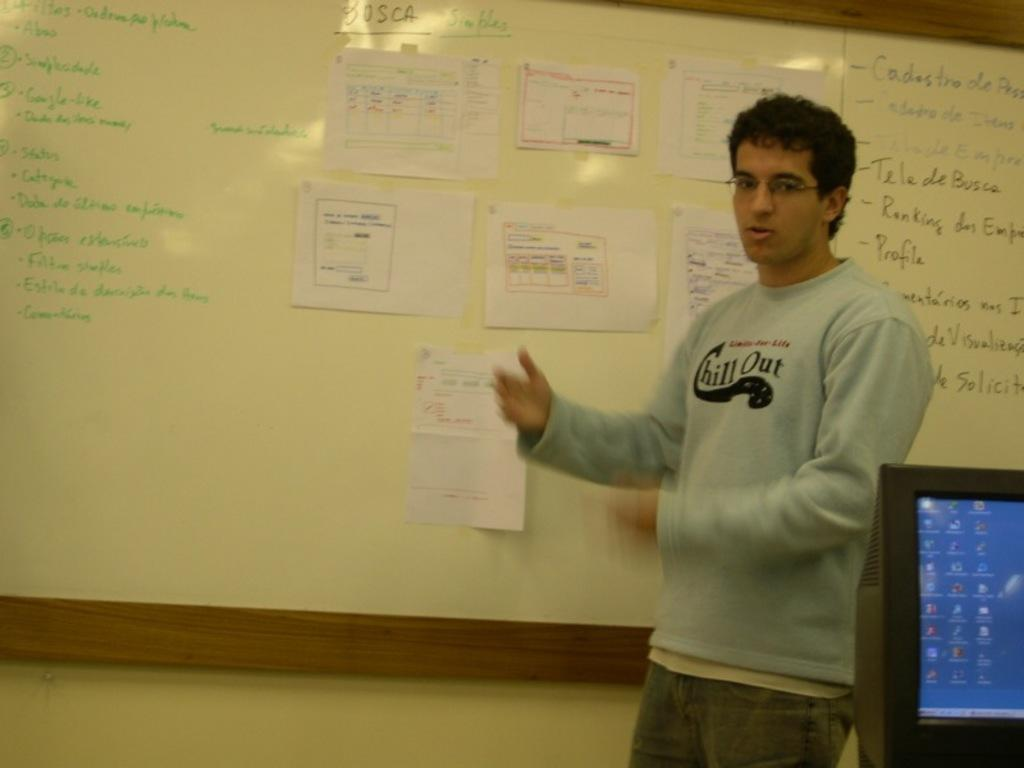Provide a one-sentence caption for the provided image. A man wears a sweatshirt with the words chill out on it as he stands in front of a white board. 